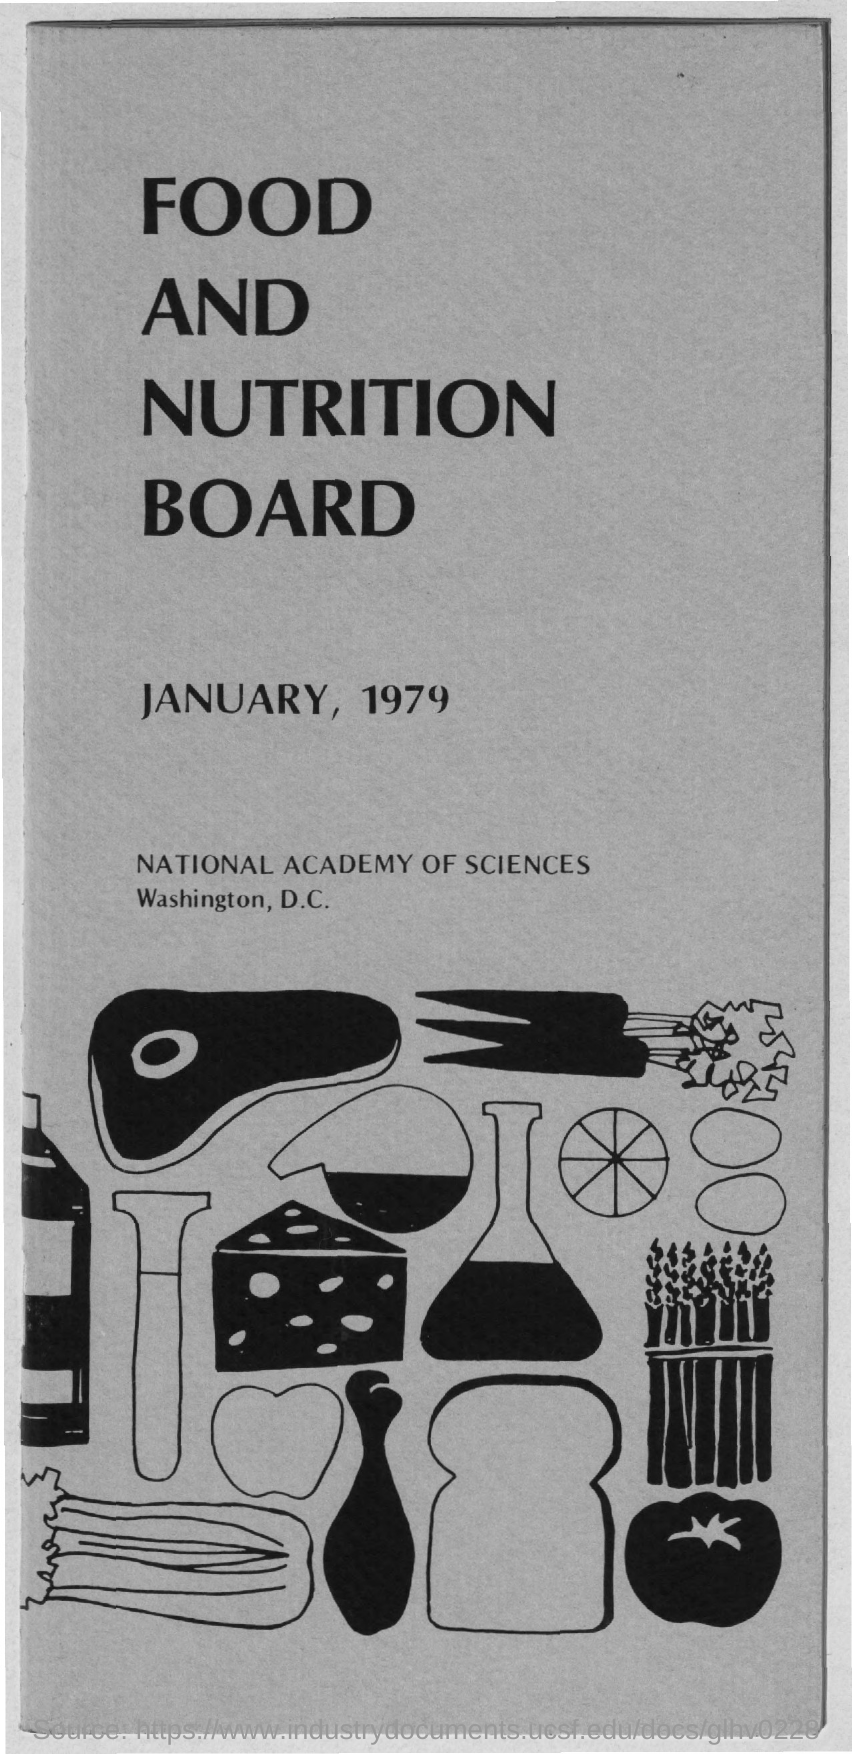What is the date on the document?
Your response must be concise. January, 1979. What is the Title of the document?
Keep it short and to the point. Food and Nutrition Board. 